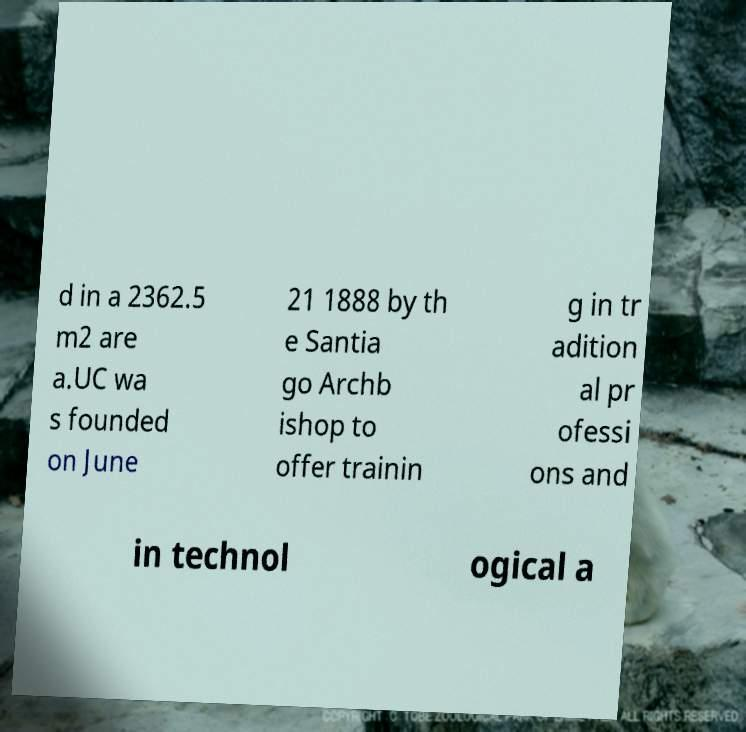Could you extract and type out the text from this image? d in a 2362.5 m2 are a.UC wa s founded on June 21 1888 by th e Santia go Archb ishop to offer trainin g in tr adition al pr ofessi ons and in technol ogical a 